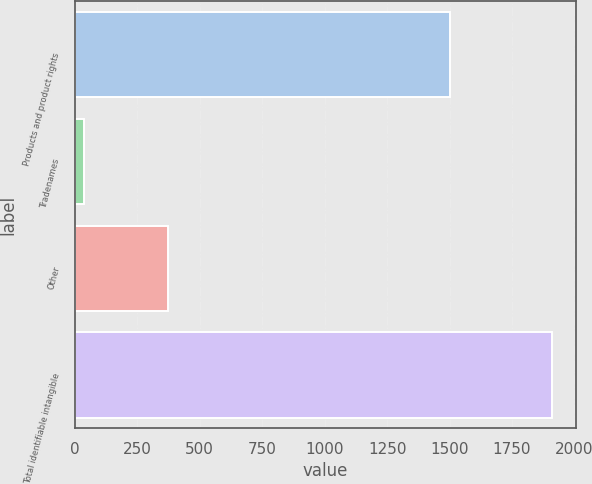Convert chart to OTSL. <chart><loc_0><loc_0><loc_500><loc_500><bar_chart><fcel>Products and product rights<fcel>Tradenames<fcel>Other<fcel>Total identifiable intangible<nl><fcel>1501.2<fcel>37.5<fcel>371.5<fcel>1910.2<nl></chart> 